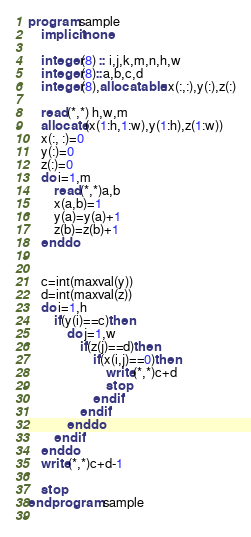<code> <loc_0><loc_0><loc_500><loc_500><_FORTRAN_>program sample
    implicit none
    
    integer(8) :: i,j,k,m,n,h,w
    integer(8)::a,b,c,d
    integer(8),allocatable::x(:,:),y(:),z(:)
  
    read(*,*) h,w,m
    allocate(x(1:h,1:w),y(1:h),z(1:w))
    x(:, :)=0
    y(:)=0
    z(:)=0
    do i=1,m
        read(*,*)a,b
        x(a,b)=1
        y(a)=y(a)+1
        z(b)=z(b)+1
    end do
    
   
    c=int(maxval(y))
    d=int(maxval(z))
    do i=1,h
        if(y(i)==c)then
            do j=1,w
                if(z(j)==d)then
                    if(x(i,j)==0)then
                        write(*,*)c+d
                        stop
                    end if
                end if
            end do
        end if
    end do
    write(*,*)c+d-1

    stop
end program sample
  

</code> 